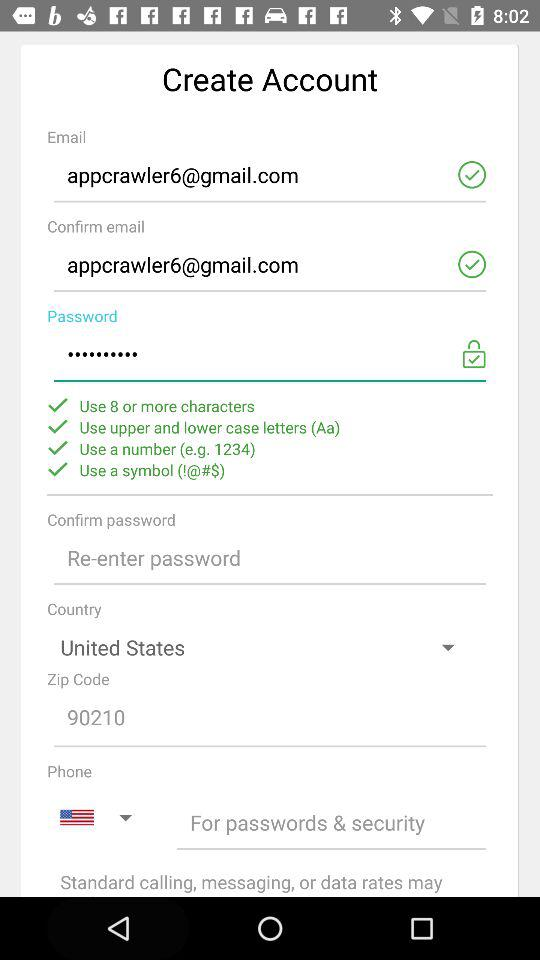What is the zip code? The zip code is 90210. 